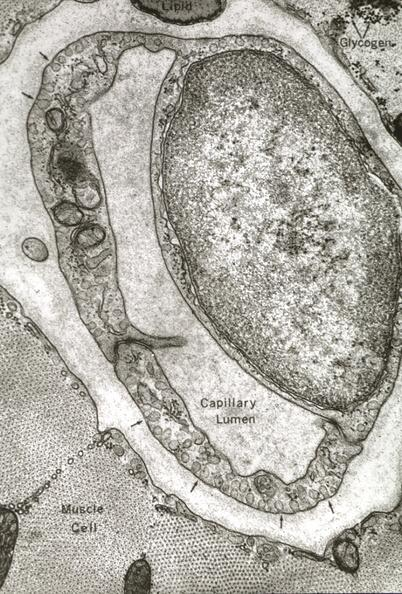where is this mage from?
Answer the question using a single word or phrase. Capillary 